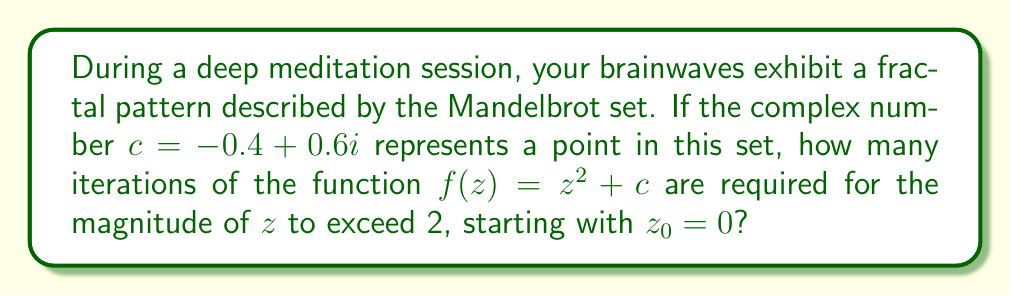Teach me how to tackle this problem. Let's approach this step-by-step:

1) We start with $z_0 = 0$ and $c = -0.4 + 0.6i$

2) We iterate the function $f(z) = z^2 + c$ until $|z| > 2$

3) Let's calculate each iteration:

   Iteration 1: $z_1 = 0^2 + (-0.4 + 0.6i) = -0.4 + 0.6i$
   $|z_1| = \sqrt{(-0.4)^2 + 0.6^2} = \sqrt{0.16 + 0.36} = \sqrt{0.52} \approx 0.721 < 2$

   Iteration 2: $z_2 = (-0.4 + 0.6i)^2 + (-0.4 + 0.6i)$
              $= (0.16 - 0.48i - 0.36) + (-0.4 + 0.6i)$
              $= -0.6 + 0.12i$
   $|z_2| = \sqrt{(-0.6)^2 + 0.12^2} = \sqrt{0.36 + 0.0144} = \sqrt{0.3744} \approx 0.612 < 2$

   Iteration 3: $z_3 = (-0.6 + 0.12i)^2 + (-0.4 + 0.6i)$
              $= (0.36 - 0.144i - 0.0144) + (-0.4 + 0.6i)$
              $= -0.0544 + 0.456i$
   $|z_3| = \sqrt{(-0.0544)^2 + 0.456^2} = \sqrt{0.00296 + 0.207936} = \sqrt{0.210896} \approx 0.459 < 2$

   Iteration 4: $z_4 = (-0.0544 + 0.456i)^2 + (-0.4 + 0.6i)$
              $= (0.00296 - 0.0496i - 0.207936) + (-0.4 + 0.6i)$
              $= -0.604976 + 0.5504i$
   $|z_4| = \sqrt{(-0.604976)^2 + 0.5504^2} = \sqrt{0.365996 + 0.302940} = \sqrt{0.668936} \approx 0.818 < 2$

   Iteration 5: $z_5 = (-0.604976 + 0.5504i)^2 + (-0.4 + 0.6i)$
              $= (0.365996 - 0.666185i - 0.302940) + (-0.4 + 0.6i)$
              $= -0.336944 - 0.066185i$
   $|z_5| = \sqrt{(-0.336944)^2 + (-0.066185)^2} = \sqrt{0.113531 + 0.004380} = \sqrt{0.117911} \approx 0.343 < 2$

We can continue this process, but it's clear that the magnitude of $z$ is not exceeding 2 within the first few iterations. In fact, this point is inside the Mandelbrot set, so the magnitude will never exceed 2 no matter how many iterations we perform.
Answer: $\infty$ (the magnitude never exceeds 2) 